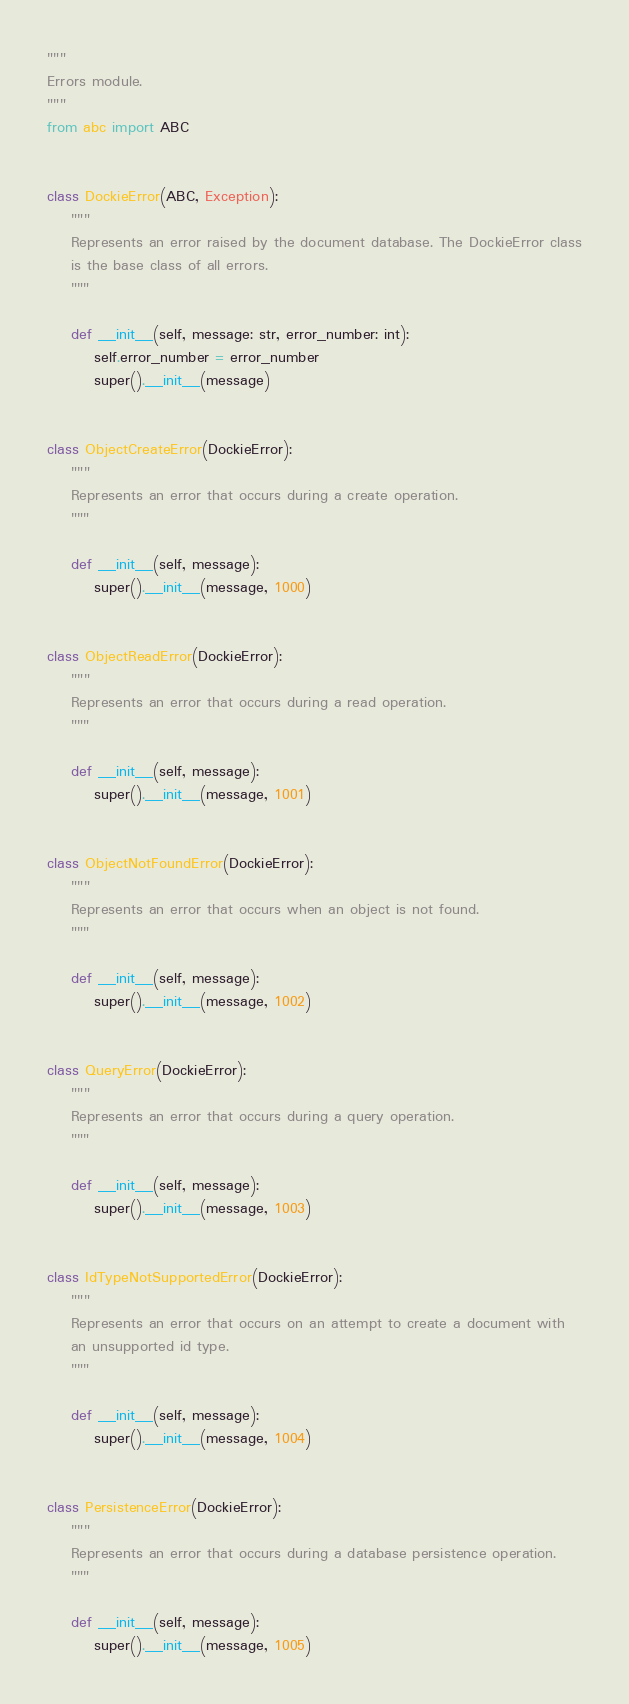<code> <loc_0><loc_0><loc_500><loc_500><_Python_>"""
Errors module.
"""
from abc import ABC


class DockieError(ABC, Exception):
    """
    Represents an error raised by the document database. The DockieError class
    is the base class of all errors.
    """

    def __init__(self, message: str, error_number: int):
        self.error_number = error_number
        super().__init__(message)


class ObjectCreateError(DockieError):
    """
    Represents an error that occurs during a create operation.
    """

    def __init__(self, message):
        super().__init__(message, 1000)


class ObjectReadError(DockieError):
    """
    Represents an error that occurs during a read operation.
    """

    def __init__(self, message):
        super().__init__(message, 1001)


class ObjectNotFoundError(DockieError):
    """
    Represents an error that occurs when an object is not found.
    """

    def __init__(self, message):
        super().__init__(message, 1002)


class QueryError(DockieError):
    """
    Represents an error that occurs during a query operation.
    """

    def __init__(self, message):
        super().__init__(message, 1003)


class IdTypeNotSupportedError(DockieError):
    """
    Represents an error that occurs on an attempt to create a document with
    an unsupported id type.
    """

    def __init__(self, message):
        super().__init__(message, 1004)


class PersistenceError(DockieError):
    """
    Represents an error that occurs during a database persistence operation.
    """

    def __init__(self, message):
        super().__init__(message, 1005)
</code> 